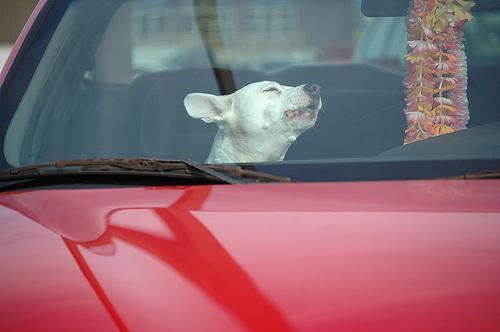How many dogs are visible?
Give a very brief answer. 1. 